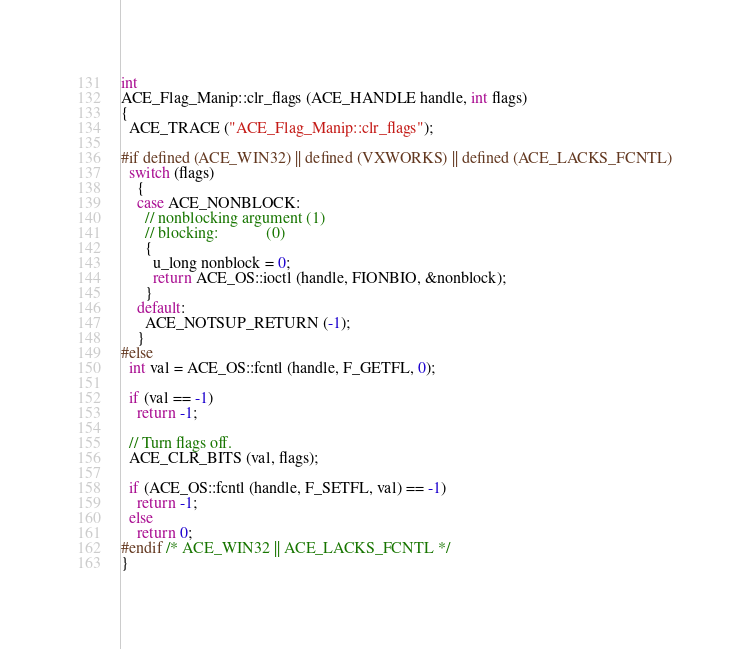Convert code to text. <code><loc_0><loc_0><loc_500><loc_500><_C++_>int
ACE_Flag_Manip::clr_flags (ACE_HANDLE handle, int flags)
{
  ACE_TRACE ("ACE_Flag_Manip::clr_flags");

#if defined (ACE_WIN32) || defined (VXWORKS) || defined (ACE_LACKS_FCNTL)
  switch (flags)
    {
    case ACE_NONBLOCK:
      // nonblocking argument (1)
      // blocking:            (0)
      {
        u_long nonblock = 0;
        return ACE_OS::ioctl (handle, FIONBIO, &nonblock);
      }
    default:
      ACE_NOTSUP_RETURN (-1);
    }
#else
  int val = ACE_OS::fcntl (handle, F_GETFL, 0);

  if (val == -1)
    return -1;

  // Turn flags off.
  ACE_CLR_BITS (val, flags);

  if (ACE_OS::fcntl (handle, F_SETFL, val) == -1)
    return -1;
  else
    return 0;
#endif /* ACE_WIN32 || ACE_LACKS_FCNTL */
}
</code> 